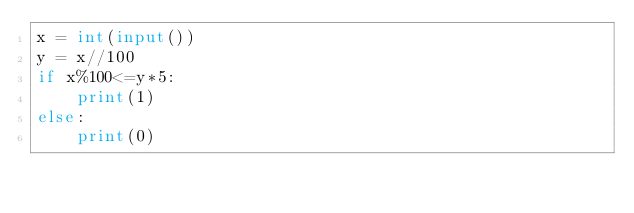Convert code to text. <code><loc_0><loc_0><loc_500><loc_500><_Python_>x = int(input())
y = x//100
if x%100<=y*5:
    print(1)
else:
    print(0)</code> 